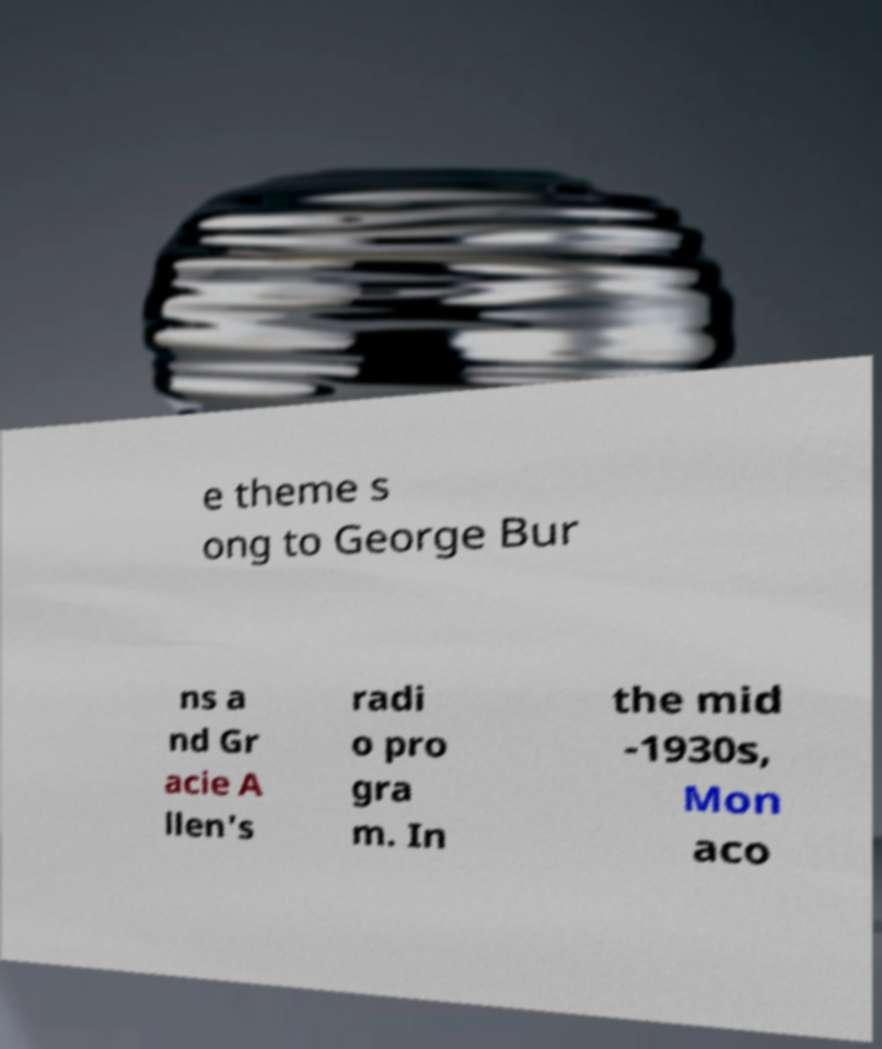For documentation purposes, I need the text within this image transcribed. Could you provide that? e theme s ong to George Bur ns a nd Gr acie A llen's radi o pro gra m. In the mid -1930s, Mon aco 